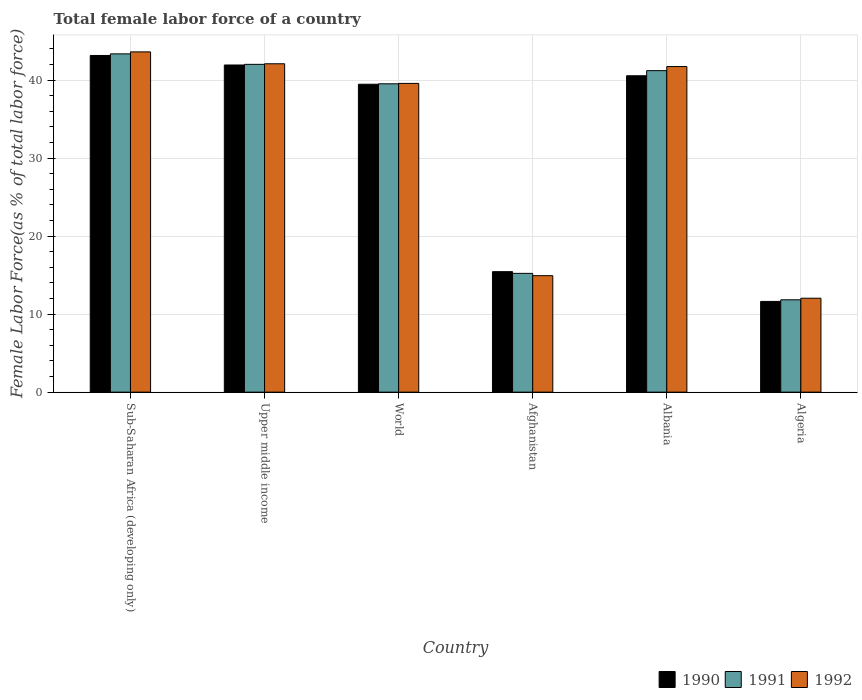How many different coloured bars are there?
Provide a succinct answer. 3. How many groups of bars are there?
Your response must be concise. 6. Are the number of bars per tick equal to the number of legend labels?
Keep it short and to the point. Yes. Are the number of bars on each tick of the X-axis equal?
Offer a terse response. Yes. How many bars are there on the 2nd tick from the right?
Keep it short and to the point. 3. What is the label of the 5th group of bars from the left?
Offer a terse response. Albania. In how many cases, is the number of bars for a given country not equal to the number of legend labels?
Your answer should be compact. 0. What is the percentage of female labor force in 1992 in Algeria?
Your answer should be compact. 12.04. Across all countries, what is the maximum percentage of female labor force in 1991?
Keep it short and to the point. 43.37. Across all countries, what is the minimum percentage of female labor force in 1992?
Give a very brief answer. 12.04. In which country was the percentage of female labor force in 1991 maximum?
Your answer should be compact. Sub-Saharan Africa (developing only). In which country was the percentage of female labor force in 1991 minimum?
Provide a short and direct response. Algeria. What is the total percentage of female labor force in 1990 in the graph?
Your answer should be very brief. 192.22. What is the difference between the percentage of female labor force in 1990 in Afghanistan and that in World?
Offer a very short reply. -24.03. What is the difference between the percentage of female labor force in 1990 in World and the percentage of female labor force in 1992 in Sub-Saharan Africa (developing only)?
Your answer should be compact. -4.15. What is the average percentage of female labor force in 1991 per country?
Make the answer very short. 32.2. What is the difference between the percentage of female labor force of/in 1990 and percentage of female labor force of/in 1992 in Upper middle income?
Your answer should be compact. -0.16. In how many countries, is the percentage of female labor force in 1991 greater than 6 %?
Offer a terse response. 6. What is the ratio of the percentage of female labor force in 1992 in Albania to that in Algeria?
Make the answer very short. 3.47. Is the percentage of female labor force in 1990 in Afghanistan less than that in Sub-Saharan Africa (developing only)?
Your response must be concise. Yes. Is the difference between the percentage of female labor force in 1990 in Afghanistan and Sub-Saharan Africa (developing only) greater than the difference between the percentage of female labor force in 1992 in Afghanistan and Sub-Saharan Africa (developing only)?
Give a very brief answer. Yes. What is the difference between the highest and the second highest percentage of female labor force in 1992?
Your response must be concise. -0.36. What is the difference between the highest and the lowest percentage of female labor force in 1990?
Give a very brief answer. 31.53. Is the sum of the percentage of female labor force in 1992 in Albania and Algeria greater than the maximum percentage of female labor force in 1990 across all countries?
Offer a terse response. Yes. What does the 1st bar from the left in Upper middle income represents?
Offer a very short reply. 1990. What does the 2nd bar from the right in Afghanistan represents?
Offer a terse response. 1991. How many bars are there?
Your answer should be compact. 18. Are all the bars in the graph horizontal?
Your answer should be compact. No. How many countries are there in the graph?
Give a very brief answer. 6. Are the values on the major ticks of Y-axis written in scientific E-notation?
Provide a succinct answer. No. Does the graph contain any zero values?
Keep it short and to the point. No. Does the graph contain grids?
Provide a short and direct response. Yes. Where does the legend appear in the graph?
Your answer should be compact. Bottom right. How are the legend labels stacked?
Give a very brief answer. Horizontal. What is the title of the graph?
Your answer should be very brief. Total female labor force of a country. Does "2015" appear as one of the legend labels in the graph?
Make the answer very short. No. What is the label or title of the X-axis?
Provide a succinct answer. Country. What is the label or title of the Y-axis?
Your answer should be very brief. Female Labor Force(as % of total labor force). What is the Female Labor Force(as % of total labor force) in 1990 in Sub-Saharan Africa (developing only)?
Your answer should be compact. 43.16. What is the Female Labor Force(as % of total labor force) of 1991 in Sub-Saharan Africa (developing only)?
Provide a succinct answer. 43.37. What is the Female Labor Force(as % of total labor force) in 1992 in Sub-Saharan Africa (developing only)?
Provide a short and direct response. 43.62. What is the Female Labor Force(as % of total labor force) in 1990 in Upper middle income?
Offer a very short reply. 41.94. What is the Female Labor Force(as % of total labor force) of 1991 in Upper middle income?
Your answer should be compact. 42.02. What is the Female Labor Force(as % of total labor force) in 1992 in Upper middle income?
Provide a succinct answer. 42.1. What is the Female Labor Force(as % of total labor force) in 1990 in World?
Make the answer very short. 39.47. What is the Female Labor Force(as % of total labor force) in 1991 in World?
Provide a short and direct response. 39.53. What is the Female Labor Force(as % of total labor force) of 1992 in World?
Provide a succinct answer. 39.58. What is the Female Labor Force(as % of total labor force) of 1990 in Afghanistan?
Ensure brevity in your answer.  15.45. What is the Female Labor Force(as % of total labor force) in 1991 in Afghanistan?
Make the answer very short. 15.23. What is the Female Labor Force(as % of total labor force) of 1992 in Afghanistan?
Make the answer very short. 14.93. What is the Female Labor Force(as % of total labor force) of 1990 in Albania?
Provide a succinct answer. 40.56. What is the Female Labor Force(as % of total labor force) in 1991 in Albania?
Give a very brief answer. 41.22. What is the Female Labor Force(as % of total labor force) in 1992 in Albania?
Provide a succinct answer. 41.74. What is the Female Labor Force(as % of total labor force) in 1990 in Algeria?
Provide a succinct answer. 11.63. What is the Female Labor Force(as % of total labor force) of 1991 in Algeria?
Ensure brevity in your answer.  11.84. What is the Female Labor Force(as % of total labor force) in 1992 in Algeria?
Your answer should be compact. 12.04. Across all countries, what is the maximum Female Labor Force(as % of total labor force) in 1990?
Your answer should be very brief. 43.16. Across all countries, what is the maximum Female Labor Force(as % of total labor force) in 1991?
Your response must be concise. 43.37. Across all countries, what is the maximum Female Labor Force(as % of total labor force) in 1992?
Your answer should be very brief. 43.62. Across all countries, what is the minimum Female Labor Force(as % of total labor force) of 1990?
Offer a very short reply. 11.63. Across all countries, what is the minimum Female Labor Force(as % of total labor force) of 1991?
Provide a short and direct response. 11.84. Across all countries, what is the minimum Female Labor Force(as % of total labor force) of 1992?
Ensure brevity in your answer.  12.04. What is the total Female Labor Force(as % of total labor force) of 1990 in the graph?
Provide a succinct answer. 192.22. What is the total Female Labor Force(as % of total labor force) of 1991 in the graph?
Keep it short and to the point. 193.2. What is the total Female Labor Force(as % of total labor force) in 1992 in the graph?
Provide a succinct answer. 194.02. What is the difference between the Female Labor Force(as % of total labor force) in 1990 in Sub-Saharan Africa (developing only) and that in Upper middle income?
Your answer should be compact. 1.22. What is the difference between the Female Labor Force(as % of total labor force) of 1991 in Sub-Saharan Africa (developing only) and that in Upper middle income?
Your response must be concise. 1.34. What is the difference between the Female Labor Force(as % of total labor force) in 1992 in Sub-Saharan Africa (developing only) and that in Upper middle income?
Offer a very short reply. 1.52. What is the difference between the Female Labor Force(as % of total labor force) in 1990 in Sub-Saharan Africa (developing only) and that in World?
Keep it short and to the point. 3.69. What is the difference between the Female Labor Force(as % of total labor force) in 1991 in Sub-Saharan Africa (developing only) and that in World?
Your answer should be very brief. 3.84. What is the difference between the Female Labor Force(as % of total labor force) in 1992 in Sub-Saharan Africa (developing only) and that in World?
Offer a very short reply. 4.04. What is the difference between the Female Labor Force(as % of total labor force) in 1990 in Sub-Saharan Africa (developing only) and that in Afghanistan?
Your answer should be very brief. 27.72. What is the difference between the Female Labor Force(as % of total labor force) of 1991 in Sub-Saharan Africa (developing only) and that in Afghanistan?
Keep it short and to the point. 28.14. What is the difference between the Female Labor Force(as % of total labor force) of 1992 in Sub-Saharan Africa (developing only) and that in Afghanistan?
Offer a terse response. 28.69. What is the difference between the Female Labor Force(as % of total labor force) of 1990 in Sub-Saharan Africa (developing only) and that in Albania?
Offer a very short reply. 2.6. What is the difference between the Female Labor Force(as % of total labor force) of 1991 in Sub-Saharan Africa (developing only) and that in Albania?
Offer a terse response. 2.15. What is the difference between the Female Labor Force(as % of total labor force) in 1992 in Sub-Saharan Africa (developing only) and that in Albania?
Your response must be concise. 1.88. What is the difference between the Female Labor Force(as % of total labor force) of 1990 in Sub-Saharan Africa (developing only) and that in Algeria?
Your response must be concise. 31.53. What is the difference between the Female Labor Force(as % of total labor force) of 1991 in Sub-Saharan Africa (developing only) and that in Algeria?
Your answer should be very brief. 31.53. What is the difference between the Female Labor Force(as % of total labor force) of 1992 in Sub-Saharan Africa (developing only) and that in Algeria?
Provide a short and direct response. 31.58. What is the difference between the Female Labor Force(as % of total labor force) in 1990 in Upper middle income and that in World?
Keep it short and to the point. 2.47. What is the difference between the Female Labor Force(as % of total labor force) of 1991 in Upper middle income and that in World?
Your answer should be compact. 2.49. What is the difference between the Female Labor Force(as % of total labor force) in 1992 in Upper middle income and that in World?
Your response must be concise. 2.52. What is the difference between the Female Labor Force(as % of total labor force) of 1990 in Upper middle income and that in Afghanistan?
Your answer should be compact. 26.5. What is the difference between the Female Labor Force(as % of total labor force) of 1991 in Upper middle income and that in Afghanistan?
Provide a short and direct response. 26.8. What is the difference between the Female Labor Force(as % of total labor force) in 1992 in Upper middle income and that in Afghanistan?
Make the answer very short. 27.17. What is the difference between the Female Labor Force(as % of total labor force) of 1990 in Upper middle income and that in Albania?
Your answer should be very brief. 1.38. What is the difference between the Female Labor Force(as % of total labor force) of 1991 in Upper middle income and that in Albania?
Provide a short and direct response. 0.81. What is the difference between the Female Labor Force(as % of total labor force) in 1992 in Upper middle income and that in Albania?
Ensure brevity in your answer.  0.36. What is the difference between the Female Labor Force(as % of total labor force) in 1990 in Upper middle income and that in Algeria?
Ensure brevity in your answer.  30.31. What is the difference between the Female Labor Force(as % of total labor force) of 1991 in Upper middle income and that in Algeria?
Ensure brevity in your answer.  30.19. What is the difference between the Female Labor Force(as % of total labor force) of 1992 in Upper middle income and that in Algeria?
Provide a succinct answer. 30.06. What is the difference between the Female Labor Force(as % of total labor force) in 1990 in World and that in Afghanistan?
Your answer should be compact. 24.03. What is the difference between the Female Labor Force(as % of total labor force) in 1991 in World and that in Afghanistan?
Offer a very short reply. 24.3. What is the difference between the Female Labor Force(as % of total labor force) of 1992 in World and that in Afghanistan?
Your answer should be compact. 24.65. What is the difference between the Female Labor Force(as % of total labor force) in 1990 in World and that in Albania?
Make the answer very short. -1.09. What is the difference between the Female Labor Force(as % of total labor force) in 1991 in World and that in Albania?
Your answer should be very brief. -1.69. What is the difference between the Female Labor Force(as % of total labor force) of 1992 in World and that in Albania?
Ensure brevity in your answer.  -2.16. What is the difference between the Female Labor Force(as % of total labor force) of 1990 in World and that in Algeria?
Offer a very short reply. 27.84. What is the difference between the Female Labor Force(as % of total labor force) in 1991 in World and that in Algeria?
Offer a terse response. 27.69. What is the difference between the Female Labor Force(as % of total labor force) of 1992 in World and that in Algeria?
Make the answer very short. 27.54. What is the difference between the Female Labor Force(as % of total labor force) of 1990 in Afghanistan and that in Albania?
Offer a very short reply. -25.12. What is the difference between the Female Labor Force(as % of total labor force) of 1991 in Afghanistan and that in Albania?
Keep it short and to the point. -25.99. What is the difference between the Female Labor Force(as % of total labor force) in 1992 in Afghanistan and that in Albania?
Your response must be concise. -26.81. What is the difference between the Female Labor Force(as % of total labor force) of 1990 in Afghanistan and that in Algeria?
Your answer should be very brief. 3.81. What is the difference between the Female Labor Force(as % of total labor force) in 1991 in Afghanistan and that in Algeria?
Offer a very short reply. 3.39. What is the difference between the Female Labor Force(as % of total labor force) in 1992 in Afghanistan and that in Algeria?
Make the answer very short. 2.89. What is the difference between the Female Labor Force(as % of total labor force) in 1990 in Albania and that in Algeria?
Offer a terse response. 28.93. What is the difference between the Female Labor Force(as % of total labor force) in 1991 in Albania and that in Algeria?
Your answer should be compact. 29.38. What is the difference between the Female Labor Force(as % of total labor force) in 1992 in Albania and that in Algeria?
Provide a short and direct response. 29.7. What is the difference between the Female Labor Force(as % of total labor force) of 1990 in Sub-Saharan Africa (developing only) and the Female Labor Force(as % of total labor force) of 1991 in Upper middle income?
Your response must be concise. 1.14. What is the difference between the Female Labor Force(as % of total labor force) in 1990 in Sub-Saharan Africa (developing only) and the Female Labor Force(as % of total labor force) in 1992 in Upper middle income?
Your answer should be compact. 1.06. What is the difference between the Female Labor Force(as % of total labor force) in 1991 in Sub-Saharan Africa (developing only) and the Female Labor Force(as % of total labor force) in 1992 in Upper middle income?
Offer a terse response. 1.27. What is the difference between the Female Labor Force(as % of total labor force) in 1990 in Sub-Saharan Africa (developing only) and the Female Labor Force(as % of total labor force) in 1991 in World?
Your response must be concise. 3.63. What is the difference between the Female Labor Force(as % of total labor force) of 1990 in Sub-Saharan Africa (developing only) and the Female Labor Force(as % of total labor force) of 1992 in World?
Make the answer very short. 3.58. What is the difference between the Female Labor Force(as % of total labor force) of 1991 in Sub-Saharan Africa (developing only) and the Female Labor Force(as % of total labor force) of 1992 in World?
Offer a terse response. 3.79. What is the difference between the Female Labor Force(as % of total labor force) of 1990 in Sub-Saharan Africa (developing only) and the Female Labor Force(as % of total labor force) of 1991 in Afghanistan?
Offer a terse response. 27.93. What is the difference between the Female Labor Force(as % of total labor force) in 1990 in Sub-Saharan Africa (developing only) and the Female Labor Force(as % of total labor force) in 1992 in Afghanistan?
Your answer should be compact. 28.23. What is the difference between the Female Labor Force(as % of total labor force) of 1991 in Sub-Saharan Africa (developing only) and the Female Labor Force(as % of total labor force) of 1992 in Afghanistan?
Keep it short and to the point. 28.44. What is the difference between the Female Labor Force(as % of total labor force) in 1990 in Sub-Saharan Africa (developing only) and the Female Labor Force(as % of total labor force) in 1991 in Albania?
Your answer should be compact. 1.94. What is the difference between the Female Labor Force(as % of total labor force) in 1990 in Sub-Saharan Africa (developing only) and the Female Labor Force(as % of total labor force) in 1992 in Albania?
Provide a succinct answer. 1.42. What is the difference between the Female Labor Force(as % of total labor force) in 1991 in Sub-Saharan Africa (developing only) and the Female Labor Force(as % of total labor force) in 1992 in Albania?
Your answer should be very brief. 1.63. What is the difference between the Female Labor Force(as % of total labor force) of 1990 in Sub-Saharan Africa (developing only) and the Female Labor Force(as % of total labor force) of 1991 in Algeria?
Provide a succinct answer. 31.32. What is the difference between the Female Labor Force(as % of total labor force) in 1990 in Sub-Saharan Africa (developing only) and the Female Labor Force(as % of total labor force) in 1992 in Algeria?
Keep it short and to the point. 31.12. What is the difference between the Female Labor Force(as % of total labor force) of 1991 in Sub-Saharan Africa (developing only) and the Female Labor Force(as % of total labor force) of 1992 in Algeria?
Your answer should be compact. 31.33. What is the difference between the Female Labor Force(as % of total labor force) in 1990 in Upper middle income and the Female Labor Force(as % of total labor force) in 1991 in World?
Ensure brevity in your answer.  2.41. What is the difference between the Female Labor Force(as % of total labor force) of 1990 in Upper middle income and the Female Labor Force(as % of total labor force) of 1992 in World?
Offer a terse response. 2.36. What is the difference between the Female Labor Force(as % of total labor force) of 1991 in Upper middle income and the Female Labor Force(as % of total labor force) of 1992 in World?
Provide a short and direct response. 2.44. What is the difference between the Female Labor Force(as % of total labor force) of 1990 in Upper middle income and the Female Labor Force(as % of total labor force) of 1991 in Afghanistan?
Give a very brief answer. 26.71. What is the difference between the Female Labor Force(as % of total labor force) in 1990 in Upper middle income and the Female Labor Force(as % of total labor force) in 1992 in Afghanistan?
Offer a very short reply. 27.01. What is the difference between the Female Labor Force(as % of total labor force) of 1991 in Upper middle income and the Female Labor Force(as % of total labor force) of 1992 in Afghanistan?
Offer a terse response. 27.09. What is the difference between the Female Labor Force(as % of total labor force) in 1990 in Upper middle income and the Female Labor Force(as % of total labor force) in 1991 in Albania?
Your answer should be very brief. 0.73. What is the difference between the Female Labor Force(as % of total labor force) in 1990 in Upper middle income and the Female Labor Force(as % of total labor force) in 1992 in Albania?
Your response must be concise. 0.2. What is the difference between the Female Labor Force(as % of total labor force) in 1991 in Upper middle income and the Female Labor Force(as % of total labor force) in 1992 in Albania?
Your answer should be compact. 0.28. What is the difference between the Female Labor Force(as % of total labor force) of 1990 in Upper middle income and the Female Labor Force(as % of total labor force) of 1991 in Algeria?
Keep it short and to the point. 30.1. What is the difference between the Female Labor Force(as % of total labor force) of 1990 in Upper middle income and the Female Labor Force(as % of total labor force) of 1992 in Algeria?
Your answer should be compact. 29.9. What is the difference between the Female Labor Force(as % of total labor force) of 1991 in Upper middle income and the Female Labor Force(as % of total labor force) of 1992 in Algeria?
Ensure brevity in your answer.  29.98. What is the difference between the Female Labor Force(as % of total labor force) of 1990 in World and the Female Labor Force(as % of total labor force) of 1991 in Afghanistan?
Your answer should be compact. 24.25. What is the difference between the Female Labor Force(as % of total labor force) in 1990 in World and the Female Labor Force(as % of total labor force) in 1992 in Afghanistan?
Provide a short and direct response. 24.54. What is the difference between the Female Labor Force(as % of total labor force) of 1991 in World and the Female Labor Force(as % of total labor force) of 1992 in Afghanistan?
Give a very brief answer. 24.6. What is the difference between the Female Labor Force(as % of total labor force) of 1990 in World and the Female Labor Force(as % of total labor force) of 1991 in Albania?
Offer a terse response. -1.74. What is the difference between the Female Labor Force(as % of total labor force) of 1990 in World and the Female Labor Force(as % of total labor force) of 1992 in Albania?
Provide a short and direct response. -2.27. What is the difference between the Female Labor Force(as % of total labor force) of 1991 in World and the Female Labor Force(as % of total labor force) of 1992 in Albania?
Keep it short and to the point. -2.21. What is the difference between the Female Labor Force(as % of total labor force) of 1990 in World and the Female Labor Force(as % of total labor force) of 1991 in Algeria?
Your answer should be very brief. 27.64. What is the difference between the Female Labor Force(as % of total labor force) of 1990 in World and the Female Labor Force(as % of total labor force) of 1992 in Algeria?
Your answer should be compact. 27.43. What is the difference between the Female Labor Force(as % of total labor force) in 1991 in World and the Female Labor Force(as % of total labor force) in 1992 in Algeria?
Make the answer very short. 27.49. What is the difference between the Female Labor Force(as % of total labor force) in 1990 in Afghanistan and the Female Labor Force(as % of total labor force) in 1991 in Albania?
Your answer should be compact. -25.77. What is the difference between the Female Labor Force(as % of total labor force) of 1990 in Afghanistan and the Female Labor Force(as % of total labor force) of 1992 in Albania?
Give a very brief answer. -26.3. What is the difference between the Female Labor Force(as % of total labor force) of 1991 in Afghanistan and the Female Labor Force(as % of total labor force) of 1992 in Albania?
Provide a succinct answer. -26.51. What is the difference between the Female Labor Force(as % of total labor force) of 1990 in Afghanistan and the Female Labor Force(as % of total labor force) of 1991 in Algeria?
Make the answer very short. 3.61. What is the difference between the Female Labor Force(as % of total labor force) of 1990 in Afghanistan and the Female Labor Force(as % of total labor force) of 1992 in Algeria?
Ensure brevity in your answer.  3.4. What is the difference between the Female Labor Force(as % of total labor force) in 1991 in Afghanistan and the Female Labor Force(as % of total labor force) in 1992 in Algeria?
Your response must be concise. 3.19. What is the difference between the Female Labor Force(as % of total labor force) of 1990 in Albania and the Female Labor Force(as % of total labor force) of 1991 in Algeria?
Make the answer very short. 28.72. What is the difference between the Female Labor Force(as % of total labor force) in 1990 in Albania and the Female Labor Force(as % of total labor force) in 1992 in Algeria?
Your response must be concise. 28.52. What is the difference between the Female Labor Force(as % of total labor force) of 1991 in Albania and the Female Labor Force(as % of total labor force) of 1992 in Algeria?
Ensure brevity in your answer.  29.17. What is the average Female Labor Force(as % of total labor force) of 1990 per country?
Your answer should be very brief. 32.04. What is the average Female Labor Force(as % of total labor force) of 1991 per country?
Give a very brief answer. 32.2. What is the average Female Labor Force(as % of total labor force) of 1992 per country?
Provide a succinct answer. 32.34. What is the difference between the Female Labor Force(as % of total labor force) in 1990 and Female Labor Force(as % of total labor force) in 1991 in Sub-Saharan Africa (developing only)?
Offer a very short reply. -0.21. What is the difference between the Female Labor Force(as % of total labor force) of 1990 and Female Labor Force(as % of total labor force) of 1992 in Sub-Saharan Africa (developing only)?
Your answer should be compact. -0.46. What is the difference between the Female Labor Force(as % of total labor force) of 1991 and Female Labor Force(as % of total labor force) of 1992 in Sub-Saharan Africa (developing only)?
Ensure brevity in your answer.  -0.25. What is the difference between the Female Labor Force(as % of total labor force) of 1990 and Female Labor Force(as % of total labor force) of 1991 in Upper middle income?
Your response must be concise. -0.08. What is the difference between the Female Labor Force(as % of total labor force) in 1990 and Female Labor Force(as % of total labor force) in 1992 in Upper middle income?
Offer a very short reply. -0.16. What is the difference between the Female Labor Force(as % of total labor force) in 1991 and Female Labor Force(as % of total labor force) in 1992 in Upper middle income?
Make the answer very short. -0.07. What is the difference between the Female Labor Force(as % of total labor force) of 1990 and Female Labor Force(as % of total labor force) of 1991 in World?
Ensure brevity in your answer.  -0.05. What is the difference between the Female Labor Force(as % of total labor force) in 1990 and Female Labor Force(as % of total labor force) in 1992 in World?
Ensure brevity in your answer.  -0.11. What is the difference between the Female Labor Force(as % of total labor force) of 1991 and Female Labor Force(as % of total labor force) of 1992 in World?
Your answer should be very brief. -0.05. What is the difference between the Female Labor Force(as % of total labor force) of 1990 and Female Labor Force(as % of total labor force) of 1991 in Afghanistan?
Provide a succinct answer. 0.22. What is the difference between the Female Labor Force(as % of total labor force) of 1990 and Female Labor Force(as % of total labor force) of 1992 in Afghanistan?
Provide a short and direct response. 0.51. What is the difference between the Female Labor Force(as % of total labor force) in 1991 and Female Labor Force(as % of total labor force) in 1992 in Afghanistan?
Keep it short and to the point. 0.3. What is the difference between the Female Labor Force(as % of total labor force) of 1990 and Female Labor Force(as % of total labor force) of 1991 in Albania?
Keep it short and to the point. -0.65. What is the difference between the Female Labor Force(as % of total labor force) of 1990 and Female Labor Force(as % of total labor force) of 1992 in Albania?
Offer a terse response. -1.18. What is the difference between the Female Labor Force(as % of total labor force) of 1991 and Female Labor Force(as % of total labor force) of 1992 in Albania?
Provide a succinct answer. -0.53. What is the difference between the Female Labor Force(as % of total labor force) of 1990 and Female Labor Force(as % of total labor force) of 1991 in Algeria?
Your answer should be very brief. -0.21. What is the difference between the Female Labor Force(as % of total labor force) of 1990 and Female Labor Force(as % of total labor force) of 1992 in Algeria?
Your response must be concise. -0.41. What is the difference between the Female Labor Force(as % of total labor force) of 1991 and Female Labor Force(as % of total labor force) of 1992 in Algeria?
Ensure brevity in your answer.  -0.2. What is the ratio of the Female Labor Force(as % of total labor force) in 1990 in Sub-Saharan Africa (developing only) to that in Upper middle income?
Your response must be concise. 1.03. What is the ratio of the Female Labor Force(as % of total labor force) of 1991 in Sub-Saharan Africa (developing only) to that in Upper middle income?
Provide a succinct answer. 1.03. What is the ratio of the Female Labor Force(as % of total labor force) in 1992 in Sub-Saharan Africa (developing only) to that in Upper middle income?
Keep it short and to the point. 1.04. What is the ratio of the Female Labor Force(as % of total labor force) in 1990 in Sub-Saharan Africa (developing only) to that in World?
Give a very brief answer. 1.09. What is the ratio of the Female Labor Force(as % of total labor force) of 1991 in Sub-Saharan Africa (developing only) to that in World?
Your answer should be very brief. 1.1. What is the ratio of the Female Labor Force(as % of total labor force) in 1992 in Sub-Saharan Africa (developing only) to that in World?
Offer a very short reply. 1.1. What is the ratio of the Female Labor Force(as % of total labor force) in 1990 in Sub-Saharan Africa (developing only) to that in Afghanistan?
Provide a succinct answer. 2.79. What is the ratio of the Female Labor Force(as % of total labor force) of 1991 in Sub-Saharan Africa (developing only) to that in Afghanistan?
Make the answer very short. 2.85. What is the ratio of the Female Labor Force(as % of total labor force) of 1992 in Sub-Saharan Africa (developing only) to that in Afghanistan?
Give a very brief answer. 2.92. What is the ratio of the Female Labor Force(as % of total labor force) of 1990 in Sub-Saharan Africa (developing only) to that in Albania?
Provide a succinct answer. 1.06. What is the ratio of the Female Labor Force(as % of total labor force) in 1991 in Sub-Saharan Africa (developing only) to that in Albania?
Offer a very short reply. 1.05. What is the ratio of the Female Labor Force(as % of total labor force) of 1992 in Sub-Saharan Africa (developing only) to that in Albania?
Provide a short and direct response. 1.04. What is the ratio of the Female Labor Force(as % of total labor force) of 1990 in Sub-Saharan Africa (developing only) to that in Algeria?
Offer a terse response. 3.71. What is the ratio of the Female Labor Force(as % of total labor force) in 1991 in Sub-Saharan Africa (developing only) to that in Algeria?
Provide a short and direct response. 3.66. What is the ratio of the Female Labor Force(as % of total labor force) of 1992 in Sub-Saharan Africa (developing only) to that in Algeria?
Your answer should be compact. 3.62. What is the ratio of the Female Labor Force(as % of total labor force) of 1990 in Upper middle income to that in World?
Your answer should be very brief. 1.06. What is the ratio of the Female Labor Force(as % of total labor force) of 1991 in Upper middle income to that in World?
Ensure brevity in your answer.  1.06. What is the ratio of the Female Labor Force(as % of total labor force) of 1992 in Upper middle income to that in World?
Your answer should be compact. 1.06. What is the ratio of the Female Labor Force(as % of total labor force) of 1990 in Upper middle income to that in Afghanistan?
Your response must be concise. 2.72. What is the ratio of the Female Labor Force(as % of total labor force) in 1991 in Upper middle income to that in Afghanistan?
Your response must be concise. 2.76. What is the ratio of the Female Labor Force(as % of total labor force) of 1992 in Upper middle income to that in Afghanistan?
Give a very brief answer. 2.82. What is the ratio of the Female Labor Force(as % of total labor force) of 1990 in Upper middle income to that in Albania?
Offer a very short reply. 1.03. What is the ratio of the Female Labor Force(as % of total labor force) of 1991 in Upper middle income to that in Albania?
Provide a succinct answer. 1.02. What is the ratio of the Female Labor Force(as % of total labor force) in 1992 in Upper middle income to that in Albania?
Provide a succinct answer. 1.01. What is the ratio of the Female Labor Force(as % of total labor force) in 1990 in Upper middle income to that in Algeria?
Make the answer very short. 3.61. What is the ratio of the Female Labor Force(as % of total labor force) in 1991 in Upper middle income to that in Algeria?
Offer a very short reply. 3.55. What is the ratio of the Female Labor Force(as % of total labor force) in 1992 in Upper middle income to that in Algeria?
Give a very brief answer. 3.5. What is the ratio of the Female Labor Force(as % of total labor force) of 1990 in World to that in Afghanistan?
Provide a short and direct response. 2.56. What is the ratio of the Female Labor Force(as % of total labor force) of 1991 in World to that in Afghanistan?
Ensure brevity in your answer.  2.6. What is the ratio of the Female Labor Force(as % of total labor force) in 1992 in World to that in Afghanistan?
Give a very brief answer. 2.65. What is the ratio of the Female Labor Force(as % of total labor force) in 1990 in World to that in Albania?
Offer a very short reply. 0.97. What is the ratio of the Female Labor Force(as % of total labor force) of 1991 in World to that in Albania?
Your answer should be compact. 0.96. What is the ratio of the Female Labor Force(as % of total labor force) of 1992 in World to that in Albania?
Your answer should be compact. 0.95. What is the ratio of the Female Labor Force(as % of total labor force) of 1990 in World to that in Algeria?
Give a very brief answer. 3.39. What is the ratio of the Female Labor Force(as % of total labor force) in 1991 in World to that in Algeria?
Ensure brevity in your answer.  3.34. What is the ratio of the Female Labor Force(as % of total labor force) in 1992 in World to that in Algeria?
Offer a very short reply. 3.29. What is the ratio of the Female Labor Force(as % of total labor force) in 1990 in Afghanistan to that in Albania?
Ensure brevity in your answer.  0.38. What is the ratio of the Female Labor Force(as % of total labor force) in 1991 in Afghanistan to that in Albania?
Offer a terse response. 0.37. What is the ratio of the Female Labor Force(as % of total labor force) of 1992 in Afghanistan to that in Albania?
Make the answer very short. 0.36. What is the ratio of the Female Labor Force(as % of total labor force) in 1990 in Afghanistan to that in Algeria?
Your answer should be very brief. 1.33. What is the ratio of the Female Labor Force(as % of total labor force) of 1991 in Afghanistan to that in Algeria?
Keep it short and to the point. 1.29. What is the ratio of the Female Labor Force(as % of total labor force) in 1992 in Afghanistan to that in Algeria?
Make the answer very short. 1.24. What is the ratio of the Female Labor Force(as % of total labor force) in 1990 in Albania to that in Algeria?
Your answer should be very brief. 3.49. What is the ratio of the Female Labor Force(as % of total labor force) of 1991 in Albania to that in Algeria?
Make the answer very short. 3.48. What is the ratio of the Female Labor Force(as % of total labor force) in 1992 in Albania to that in Algeria?
Make the answer very short. 3.47. What is the difference between the highest and the second highest Female Labor Force(as % of total labor force) of 1990?
Your answer should be very brief. 1.22. What is the difference between the highest and the second highest Female Labor Force(as % of total labor force) in 1991?
Provide a succinct answer. 1.34. What is the difference between the highest and the second highest Female Labor Force(as % of total labor force) in 1992?
Provide a short and direct response. 1.52. What is the difference between the highest and the lowest Female Labor Force(as % of total labor force) of 1990?
Offer a terse response. 31.53. What is the difference between the highest and the lowest Female Labor Force(as % of total labor force) of 1991?
Offer a very short reply. 31.53. What is the difference between the highest and the lowest Female Labor Force(as % of total labor force) in 1992?
Give a very brief answer. 31.58. 